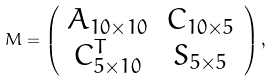Convert formula to latex. <formula><loc_0><loc_0><loc_500><loc_500>M = \left ( \begin{array} [ c ] { c c } A _ { 1 0 \times 1 0 } & C _ { 1 0 \times 5 } \\ C ^ { T } _ { 5 \times 1 0 } & S _ { 5 \times 5 } \end{array} \right ) ,</formula> 